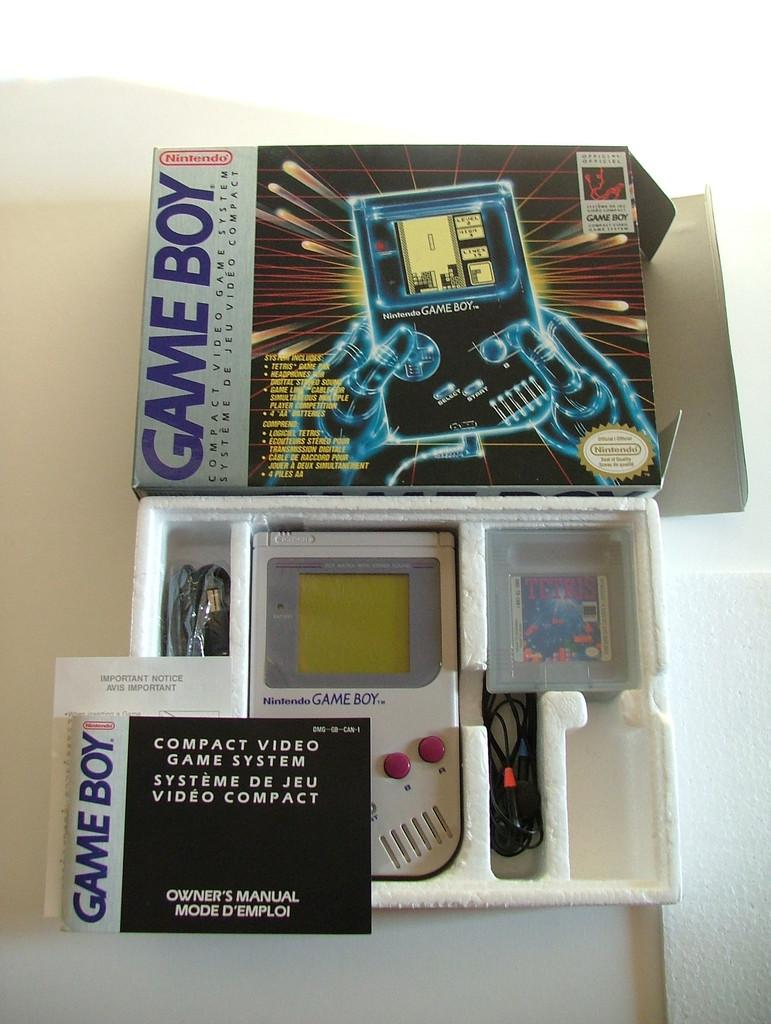<image>
Share a concise interpretation of the image provided. A Game Boy is in an open package with the top of the box above. 